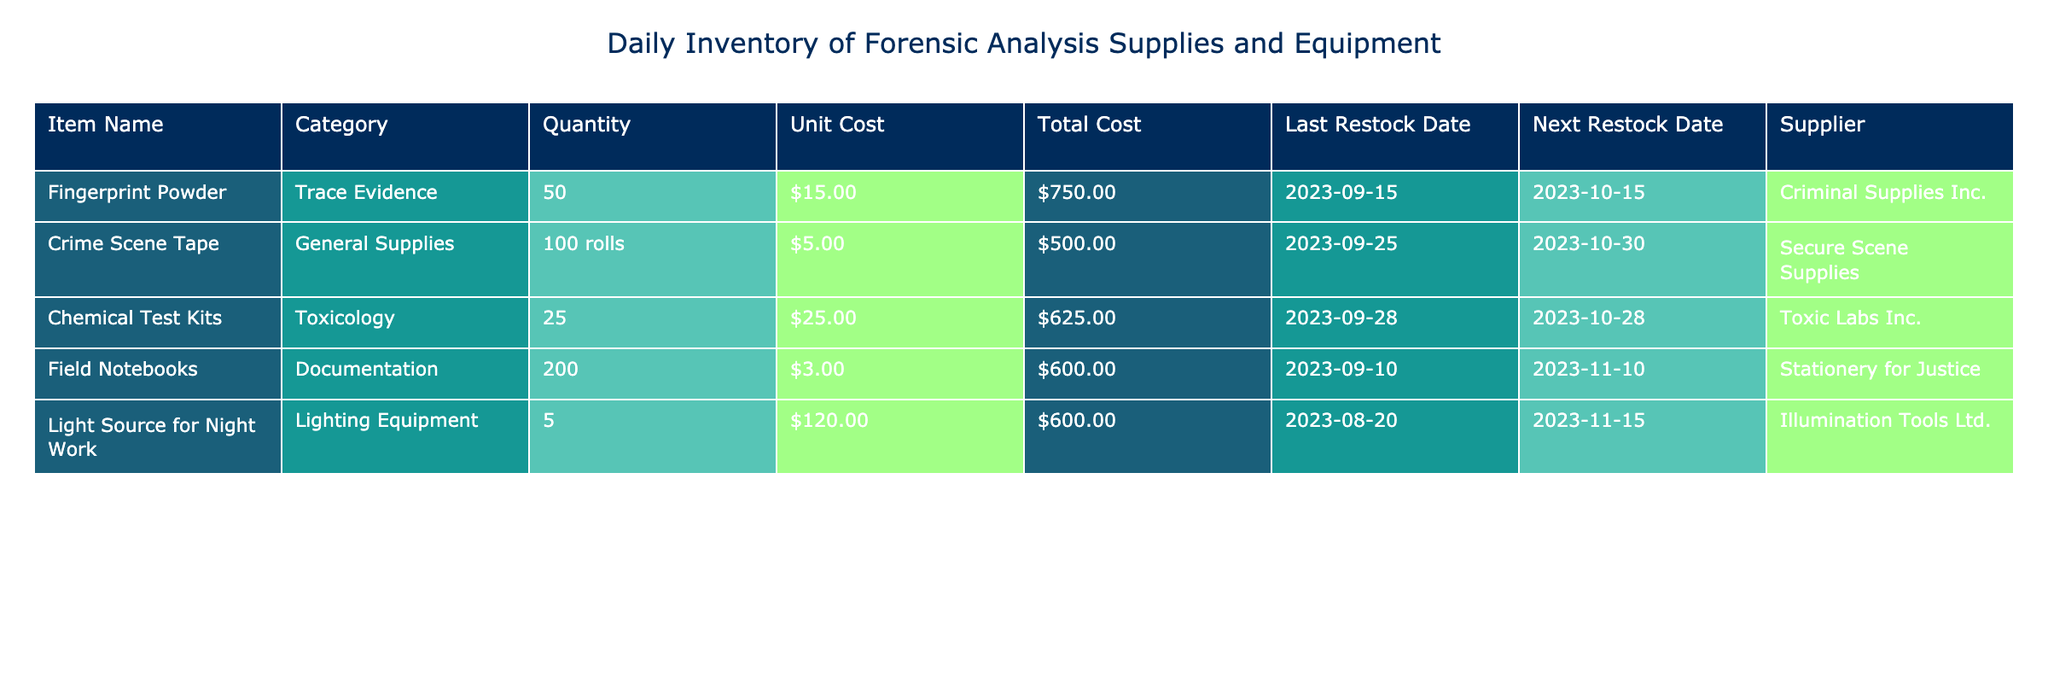What is the total quantity of Crime Scene Tape available? The table shows that the quantity of Crime Scene Tape is listed as 100 rolls. Therefore, the total quantity available is simply the value provided in that row.
Answer: 100 rolls What is the total cost of Fingerprint Powder? The total cost for Fingerprint Powder can be found directly in the table, which states the Total Cost is $750.00.
Answer: $750.00 How many items are in the Toxicology category? There is only one item listed in the Toxicology category, which is the Chemical Test Kits. This can be confirmed by counting the number of entries under that category in the table.
Answer: 1 What is the average unit cost of all the items in the inventory? The unit costs for the items are $15.00, $5.00, $25.00, $3.00, and $120.00. To find the average, first sum them: 15 + 5 + 25 + 3 + 120 = 168. There are 5 items, so the average is 168/5 = 33.6.
Answer: $33.60 Is the next restock date for Field Notebooks after October 10, 2023? The next restock date for Field Notebooks is listed as November 10, 2023, which is after October 10, 2023. Thus, the statement is true.
Answer: Yes What is the difference in total cost between the most expensive and least expensive item? The most expensive item is the Light Source for Night Work with a total cost of $600.00, and the least expensive item is the Crime Scene Tape with a total cost of $500.00. The difference is 600 - 500 = 100.
Answer: $100.00 How many different categories are represented in this inventory table? The categories listed in the table are Trace Evidence, General Supplies, Toxicology, Documentation, and Lighting Equipment. Counting these categories gives a total of 5 different categories.
Answer: 5 What is the next restock date for Chemical Test Kits? In the table, the next restock date for Chemical Test Kits is mentioned as October 28, 2023. This can be found directly in the corresponding row for this item.
Answer: October 28, 2023 